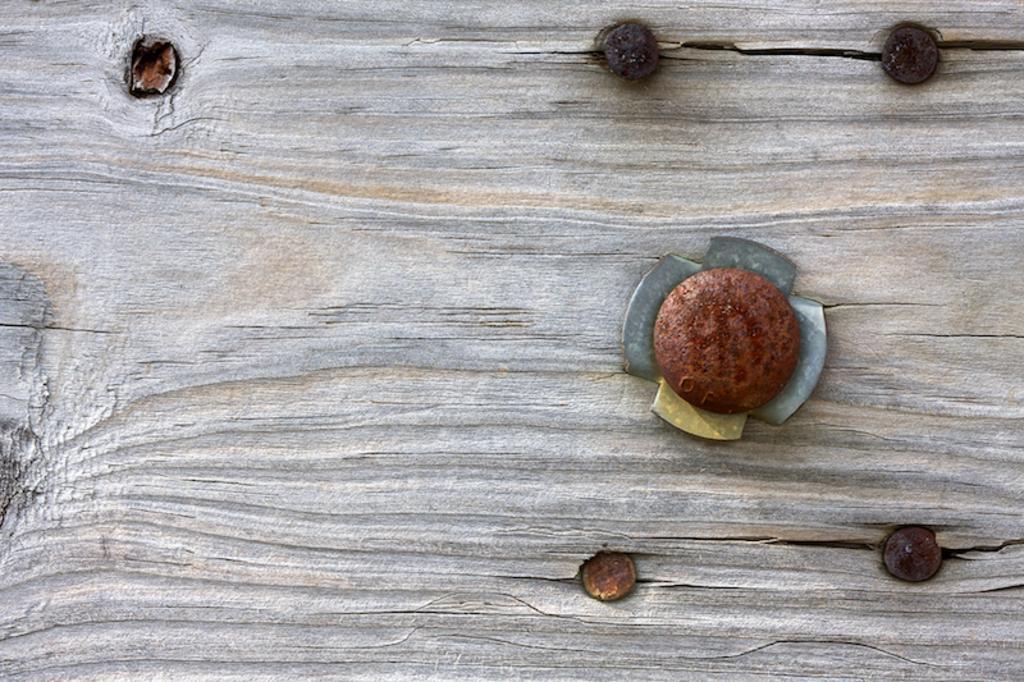Describe this image in one or two sentences. In the image on the wooden surface there are nails. 